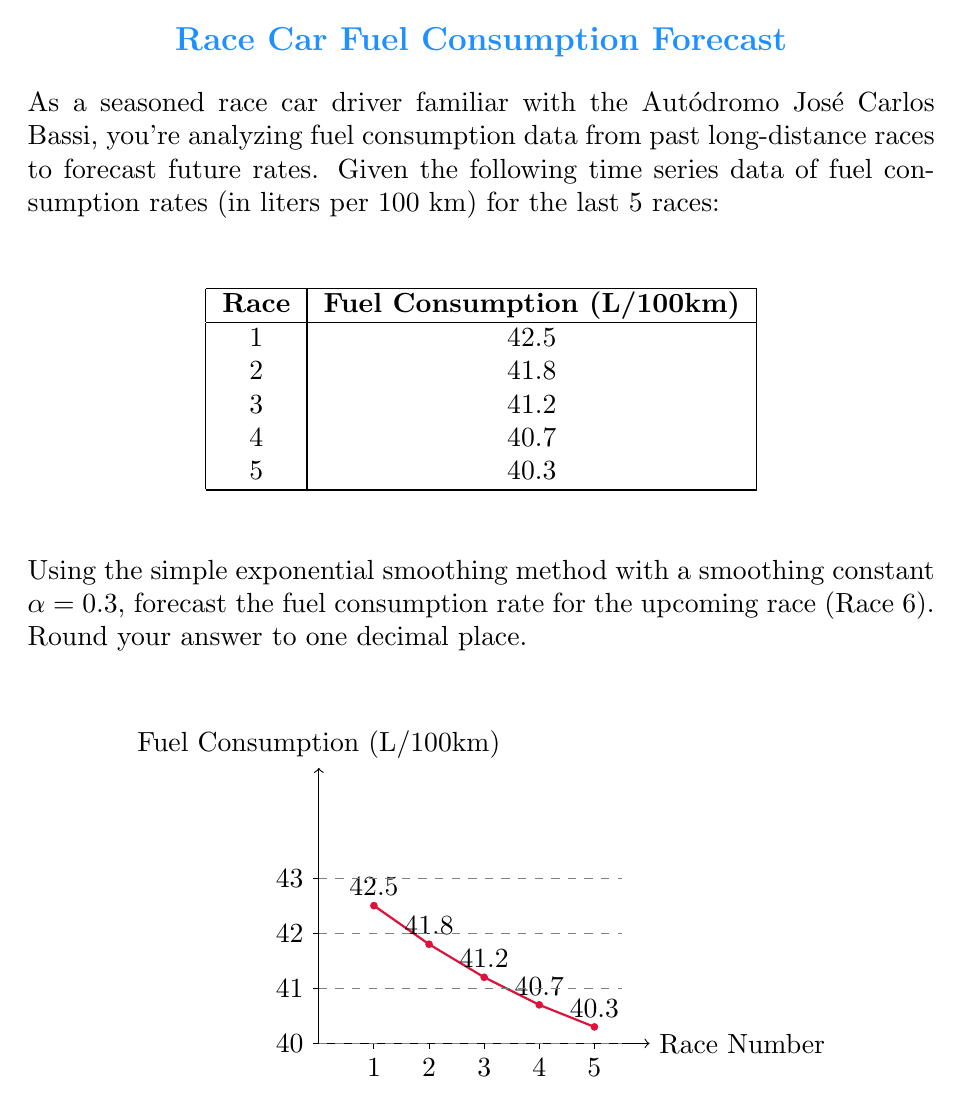What is the answer to this math problem? To forecast the fuel consumption rate using simple exponential smoothing, we'll follow these steps:

1) The formula for simple exponential smoothing is:

   $$F_{t+1} = \alpha Y_t + (1-\alpha)F_t$$

   Where:
   $F_{t+1}$ is the forecast for the next period
   $Y_t$ is the actual value at time t
   $F_t$ is the forecast for the current period
   $\alpha$ is the smoothing constant (0.3 in this case)

2) We start by setting $F_1 = Y_1 = 42.5$ (the first actual value)

3) Now we calculate the forecasts for each period:

   For Race 2: $F_2 = 0.3(42.5) + 0.7(42.5) = 42.5$
   For Race 3: $F_3 = 0.3(41.8) + 0.7(42.5) = 42.29$
   For Race 4: $F_4 = 0.3(41.2) + 0.7(42.29) = 41.963$
   For Race 5: $F_5 = 0.3(40.7) + 0.7(41.963) = 41.5741$

4) Finally, we can forecast for Race 6:

   $F_6 = 0.3(40.3) + 0.7(41.5741) = 41.2019$

5) Rounding to one decimal place: 41.2
Answer: 41.2 L/100km 